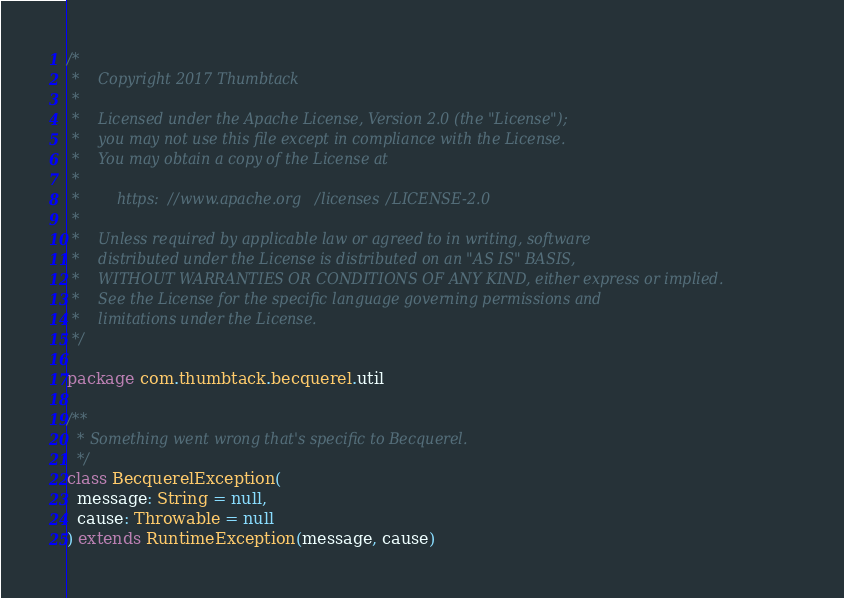<code> <loc_0><loc_0><loc_500><loc_500><_Scala_>/*
 *    Copyright 2017 Thumbtack
 *
 *    Licensed under the Apache License, Version 2.0 (the "License");
 *    you may not use this file except in compliance with the License.
 *    You may obtain a copy of the License at
 *
 *        https://www.apache.org/licenses/LICENSE-2.0
 *
 *    Unless required by applicable law or agreed to in writing, software
 *    distributed under the License is distributed on an "AS IS" BASIS,
 *    WITHOUT WARRANTIES OR CONDITIONS OF ANY KIND, either express or implied.
 *    See the License for the specific language governing permissions and
 *    limitations under the License.
 */

package com.thumbtack.becquerel.util

/**
  * Something went wrong that's specific to Becquerel.
  */
class BecquerelException(
  message: String = null,
  cause: Throwable = null
) extends RuntimeException(message, cause)
</code> 